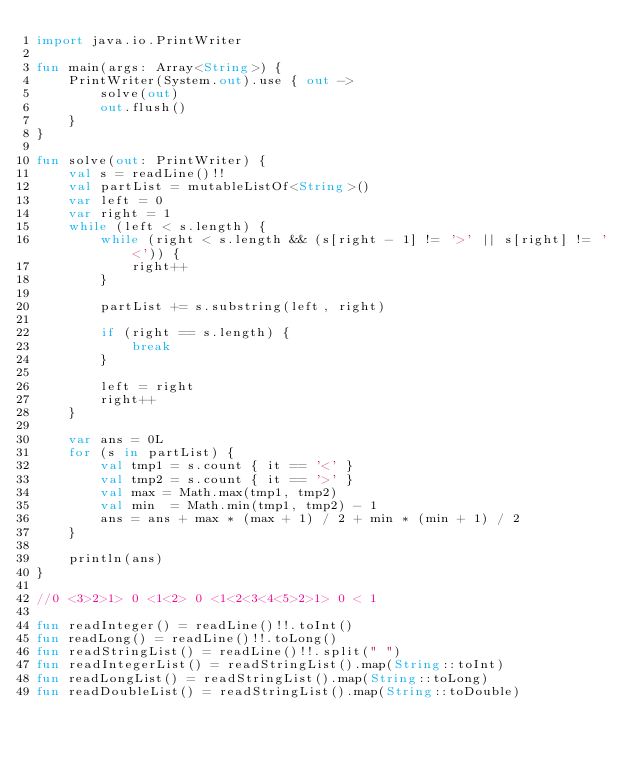<code> <loc_0><loc_0><loc_500><loc_500><_Kotlin_>import java.io.PrintWriter

fun main(args: Array<String>) {
    PrintWriter(System.out).use { out ->
        solve(out)
        out.flush()
    }
}

fun solve(out: PrintWriter) {
    val s = readLine()!!
    val partList = mutableListOf<String>()
    var left = 0
    var right = 1
    while (left < s.length) {
        while (right < s.length && (s[right - 1] != '>' || s[right] != '<')) {
            right++
        }

        partList += s.substring(left, right)

        if (right == s.length) {
            break
        }

        left = right
        right++
    }

    var ans = 0L
    for (s in partList) {
        val tmp1 = s.count { it == '<' }
        val tmp2 = s.count { it == '>' }
        val max = Math.max(tmp1, tmp2) 
        val min  = Math.min(tmp1, tmp2) - 1
        ans = ans + max * (max + 1) / 2 + min * (min + 1) / 2
    }

    println(ans)
}

//0 <3>2>1> 0 <1<2> 0 <1<2<3<4<5>2>1> 0 < 1

fun readInteger() = readLine()!!.toInt()
fun readLong() = readLine()!!.toLong()
fun readStringList() = readLine()!!.split(" ")
fun readIntegerList() = readStringList().map(String::toInt)
fun readLongList() = readStringList().map(String::toLong)
fun readDoubleList() = readStringList().map(String::toDouble)
</code> 